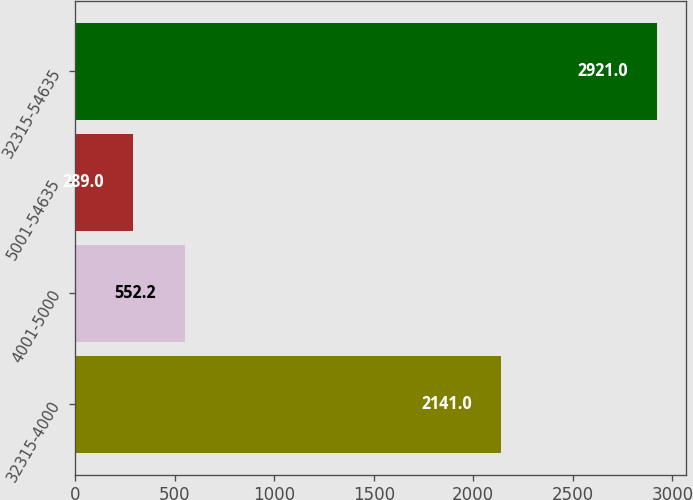Convert chart to OTSL. <chart><loc_0><loc_0><loc_500><loc_500><bar_chart><fcel>32315-4000<fcel>4001-5000<fcel>5001-54635<fcel>32315-54635<nl><fcel>2141<fcel>552.2<fcel>289<fcel>2921<nl></chart> 